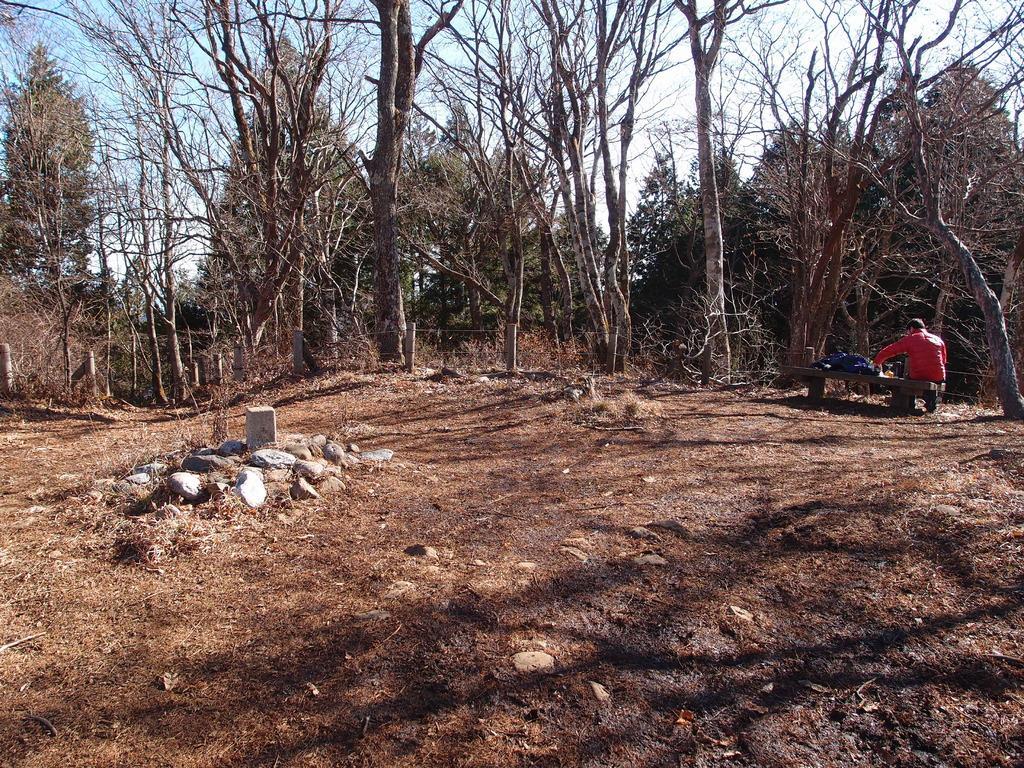Can you describe this image briefly? On the right side of the image we can see a man is sitting on a bench and wearing a jacket, beside him we can see a cloth. In the background of the image we can see the trees, fence, dry leaves, stones. At the bottom of the image we can see the ground. At the top of the image we can see the sky. 